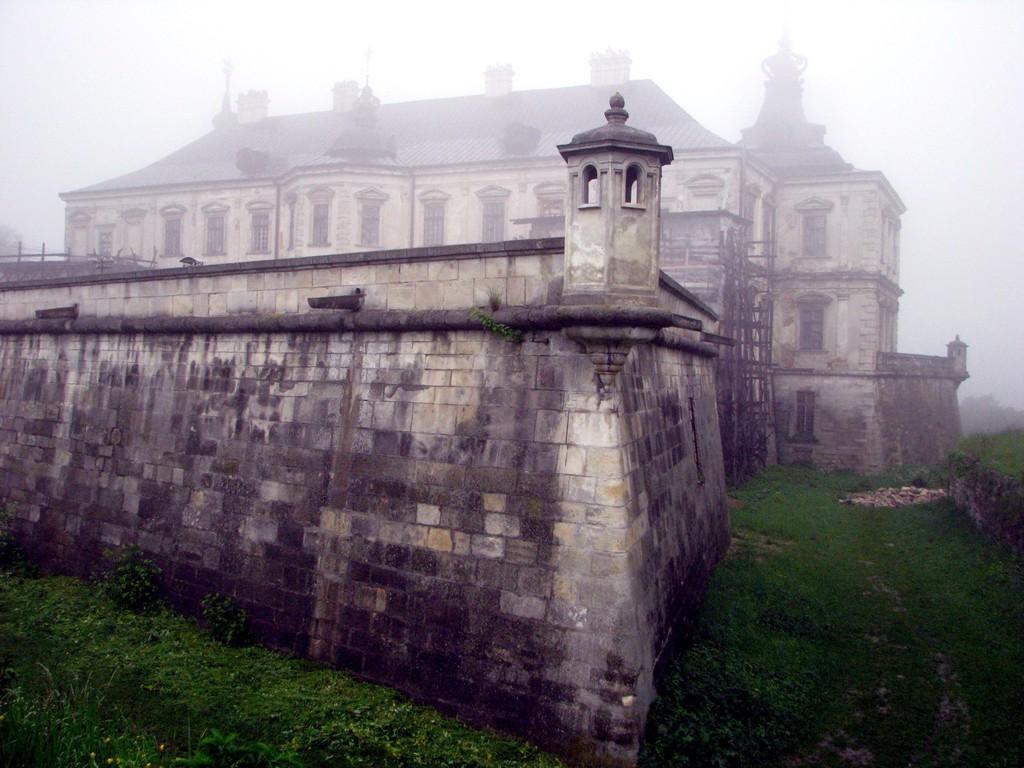Please provide a concise description of this image. Background portion of the picture is blurry and we can see the sky. In this picture we can see a building, windows, roof top and the wooden poles. We can see the tiny plants and few stones. 